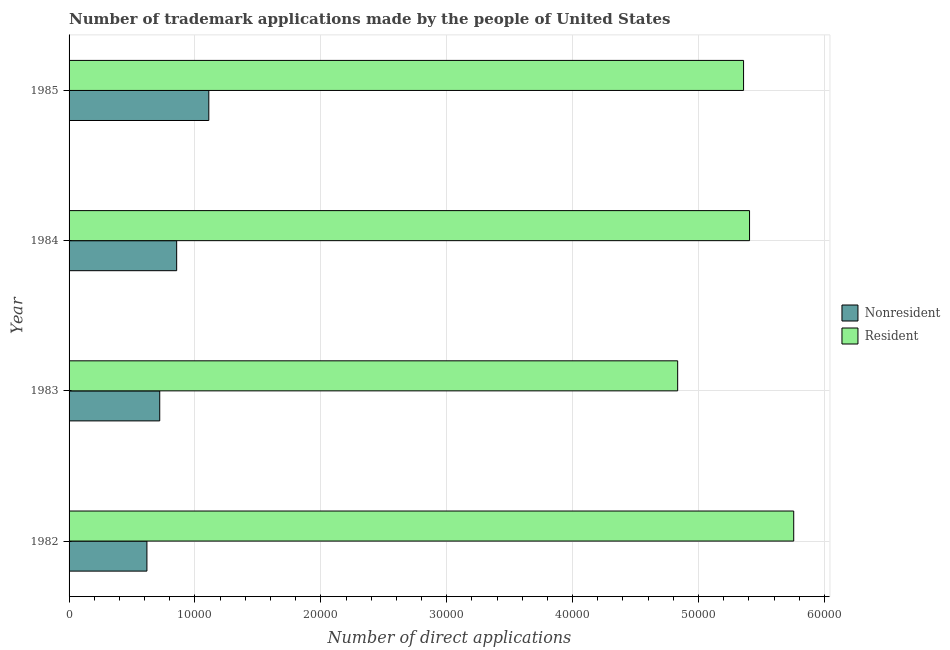How many bars are there on the 3rd tick from the top?
Your answer should be very brief. 2. In how many cases, is the number of bars for a given year not equal to the number of legend labels?
Make the answer very short. 0. What is the number of trademark applications made by non residents in 1983?
Give a very brief answer. 7202. Across all years, what is the maximum number of trademark applications made by residents?
Your response must be concise. 5.76e+04. Across all years, what is the minimum number of trademark applications made by non residents?
Your answer should be very brief. 6184. In which year was the number of trademark applications made by residents maximum?
Your answer should be compact. 1982. What is the total number of trademark applications made by residents in the graph?
Keep it short and to the point. 2.14e+05. What is the difference between the number of trademark applications made by residents in 1982 and that in 1983?
Your answer should be very brief. 9218. What is the difference between the number of trademark applications made by non residents in 1984 and the number of trademark applications made by residents in 1982?
Keep it short and to the point. -4.90e+04. What is the average number of trademark applications made by non residents per year?
Your answer should be compact. 8258.25. In the year 1985, what is the difference between the number of trademark applications made by non residents and number of trademark applications made by residents?
Make the answer very short. -4.25e+04. What is the ratio of the number of trademark applications made by residents in 1982 to that in 1985?
Make the answer very short. 1.07. Is the number of trademark applications made by residents in 1983 less than that in 1985?
Offer a very short reply. Yes. What is the difference between the highest and the second highest number of trademark applications made by non residents?
Keep it short and to the point. 2553. What is the difference between the highest and the lowest number of trademark applications made by non residents?
Provide a succinct answer. 4916. In how many years, is the number of trademark applications made by non residents greater than the average number of trademark applications made by non residents taken over all years?
Keep it short and to the point. 2. What does the 2nd bar from the top in 1983 represents?
Give a very brief answer. Nonresident. What does the 1st bar from the bottom in 1985 represents?
Keep it short and to the point. Nonresident. How many years are there in the graph?
Your answer should be very brief. 4. What is the difference between two consecutive major ticks on the X-axis?
Provide a short and direct response. 10000. Are the values on the major ticks of X-axis written in scientific E-notation?
Make the answer very short. No. Does the graph contain any zero values?
Offer a very short reply. No. Where does the legend appear in the graph?
Provide a succinct answer. Center right. What is the title of the graph?
Provide a short and direct response. Number of trademark applications made by the people of United States. What is the label or title of the X-axis?
Make the answer very short. Number of direct applications. What is the label or title of the Y-axis?
Your answer should be compact. Year. What is the Number of direct applications of Nonresident in 1982?
Your answer should be very brief. 6184. What is the Number of direct applications in Resident in 1982?
Your response must be concise. 5.76e+04. What is the Number of direct applications of Nonresident in 1983?
Ensure brevity in your answer.  7202. What is the Number of direct applications of Resident in 1983?
Offer a terse response. 4.83e+04. What is the Number of direct applications of Nonresident in 1984?
Offer a very short reply. 8547. What is the Number of direct applications in Resident in 1984?
Keep it short and to the point. 5.41e+04. What is the Number of direct applications in Nonresident in 1985?
Your answer should be compact. 1.11e+04. What is the Number of direct applications in Resident in 1985?
Keep it short and to the point. 5.36e+04. Across all years, what is the maximum Number of direct applications in Nonresident?
Offer a terse response. 1.11e+04. Across all years, what is the maximum Number of direct applications in Resident?
Your answer should be very brief. 5.76e+04. Across all years, what is the minimum Number of direct applications of Nonresident?
Your answer should be compact. 6184. Across all years, what is the minimum Number of direct applications in Resident?
Ensure brevity in your answer.  4.83e+04. What is the total Number of direct applications in Nonresident in the graph?
Your response must be concise. 3.30e+04. What is the total Number of direct applications in Resident in the graph?
Your answer should be compact. 2.14e+05. What is the difference between the Number of direct applications in Nonresident in 1982 and that in 1983?
Your answer should be compact. -1018. What is the difference between the Number of direct applications of Resident in 1982 and that in 1983?
Offer a very short reply. 9218. What is the difference between the Number of direct applications in Nonresident in 1982 and that in 1984?
Your response must be concise. -2363. What is the difference between the Number of direct applications in Resident in 1982 and that in 1984?
Provide a succinct answer. 3508. What is the difference between the Number of direct applications in Nonresident in 1982 and that in 1985?
Make the answer very short. -4916. What is the difference between the Number of direct applications of Resident in 1982 and that in 1985?
Make the answer very short. 3984. What is the difference between the Number of direct applications of Nonresident in 1983 and that in 1984?
Provide a succinct answer. -1345. What is the difference between the Number of direct applications of Resident in 1983 and that in 1984?
Offer a terse response. -5710. What is the difference between the Number of direct applications in Nonresident in 1983 and that in 1985?
Your response must be concise. -3898. What is the difference between the Number of direct applications of Resident in 1983 and that in 1985?
Your response must be concise. -5234. What is the difference between the Number of direct applications of Nonresident in 1984 and that in 1985?
Your answer should be compact. -2553. What is the difference between the Number of direct applications of Resident in 1984 and that in 1985?
Make the answer very short. 476. What is the difference between the Number of direct applications in Nonresident in 1982 and the Number of direct applications in Resident in 1983?
Give a very brief answer. -4.22e+04. What is the difference between the Number of direct applications of Nonresident in 1982 and the Number of direct applications of Resident in 1984?
Offer a terse response. -4.79e+04. What is the difference between the Number of direct applications of Nonresident in 1982 and the Number of direct applications of Resident in 1985?
Your answer should be compact. -4.74e+04. What is the difference between the Number of direct applications in Nonresident in 1983 and the Number of direct applications in Resident in 1984?
Your response must be concise. -4.69e+04. What is the difference between the Number of direct applications in Nonresident in 1983 and the Number of direct applications in Resident in 1985?
Offer a very short reply. -4.64e+04. What is the difference between the Number of direct applications of Nonresident in 1984 and the Number of direct applications of Resident in 1985?
Provide a short and direct response. -4.50e+04. What is the average Number of direct applications of Nonresident per year?
Your response must be concise. 8258.25. What is the average Number of direct applications in Resident per year?
Give a very brief answer. 5.34e+04. In the year 1982, what is the difference between the Number of direct applications of Nonresident and Number of direct applications of Resident?
Provide a succinct answer. -5.14e+04. In the year 1983, what is the difference between the Number of direct applications of Nonresident and Number of direct applications of Resident?
Provide a short and direct response. -4.11e+04. In the year 1984, what is the difference between the Number of direct applications in Nonresident and Number of direct applications in Resident?
Give a very brief answer. -4.55e+04. In the year 1985, what is the difference between the Number of direct applications of Nonresident and Number of direct applications of Resident?
Your answer should be very brief. -4.25e+04. What is the ratio of the Number of direct applications of Nonresident in 1982 to that in 1983?
Your answer should be very brief. 0.86. What is the ratio of the Number of direct applications of Resident in 1982 to that in 1983?
Ensure brevity in your answer.  1.19. What is the ratio of the Number of direct applications of Nonresident in 1982 to that in 1984?
Your answer should be very brief. 0.72. What is the ratio of the Number of direct applications in Resident in 1982 to that in 1984?
Make the answer very short. 1.06. What is the ratio of the Number of direct applications of Nonresident in 1982 to that in 1985?
Provide a succinct answer. 0.56. What is the ratio of the Number of direct applications in Resident in 1982 to that in 1985?
Make the answer very short. 1.07. What is the ratio of the Number of direct applications of Nonresident in 1983 to that in 1984?
Offer a very short reply. 0.84. What is the ratio of the Number of direct applications of Resident in 1983 to that in 1984?
Provide a succinct answer. 0.89. What is the ratio of the Number of direct applications in Nonresident in 1983 to that in 1985?
Offer a very short reply. 0.65. What is the ratio of the Number of direct applications in Resident in 1983 to that in 1985?
Make the answer very short. 0.9. What is the ratio of the Number of direct applications in Nonresident in 1984 to that in 1985?
Provide a succinct answer. 0.77. What is the ratio of the Number of direct applications in Resident in 1984 to that in 1985?
Your answer should be very brief. 1.01. What is the difference between the highest and the second highest Number of direct applications of Nonresident?
Ensure brevity in your answer.  2553. What is the difference between the highest and the second highest Number of direct applications of Resident?
Give a very brief answer. 3508. What is the difference between the highest and the lowest Number of direct applications of Nonresident?
Provide a succinct answer. 4916. What is the difference between the highest and the lowest Number of direct applications in Resident?
Your answer should be very brief. 9218. 